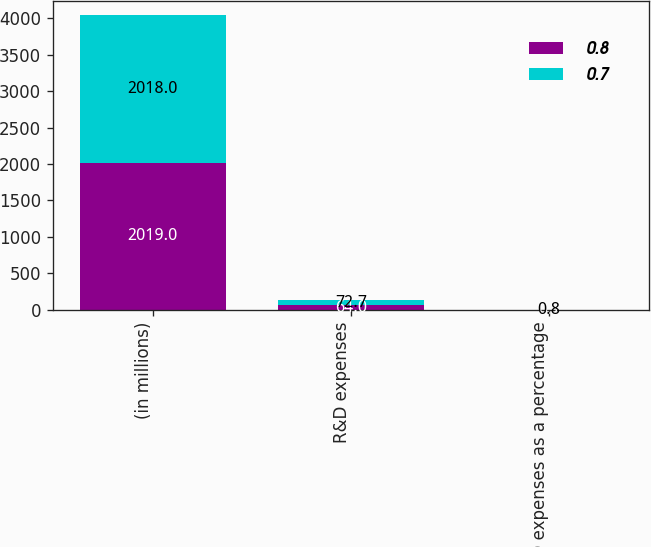Convert chart. <chart><loc_0><loc_0><loc_500><loc_500><stacked_bar_chart><ecel><fcel>(in millions)<fcel>R&D expenses<fcel>R&D expenses as a percentage<nl><fcel>0.8<fcel>2019<fcel>64<fcel>0.7<nl><fcel>0.7<fcel>2018<fcel>72.7<fcel>0.8<nl></chart> 